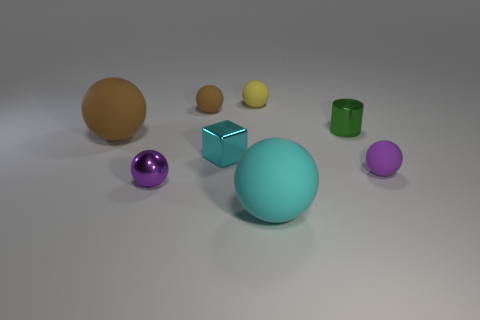There is a yellow object that is the same size as the block; what is its material?
Give a very brief answer. Rubber. There is a green thing; are there any small rubber spheres to the left of it?
Provide a short and direct response. Yes. Are there the same number of small things behind the tiny cube and large cyan rubber balls?
Your answer should be very brief. No. What is the shape of the brown matte thing that is the same size as the purple matte thing?
Make the answer very short. Sphere. What material is the cyan ball?
Give a very brief answer. Rubber. What is the color of the small thing that is in front of the tiny cyan metal block and to the right of the tiny shiny block?
Make the answer very short. Purple. Are there an equal number of things behind the cyan matte object and balls to the right of the small cube?
Your response must be concise. No. What is the color of the big object that is the same material as the cyan sphere?
Your response must be concise. Brown. There is a metal sphere; is it the same color as the big ball to the left of the tiny brown thing?
Ensure brevity in your answer.  No. Are there any matte balls to the left of the rubber object that is on the right side of the cyan object to the right of the cyan block?
Keep it short and to the point. Yes. 